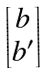Convert formula to latex. <formula><loc_0><loc_0><loc_500><loc_500>\begin{bmatrix} b \\ b ^ { \prime } \end{bmatrix}</formula> 